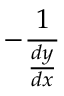<formula> <loc_0><loc_0><loc_500><loc_500>- { \frac { 1 } { \frac { d y } { d x } } }</formula> 